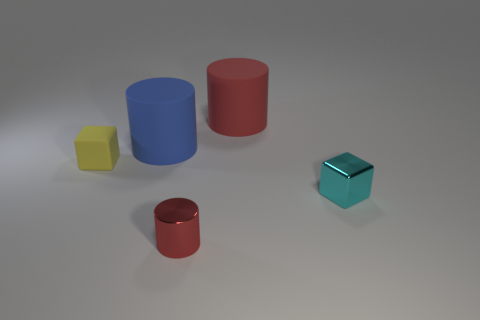What is the color of the other tiny metal thing that is the same shape as the tiny yellow object?
Make the answer very short. Cyan. What number of small red shiny objects are the same shape as the big red rubber thing?
Ensure brevity in your answer.  1. What number of things are either tiny rubber objects or red objects that are behind the tiny cylinder?
Your answer should be very brief. 2. There is a small shiny cube; does it have the same color as the block behind the tiny cyan object?
Offer a terse response. No. There is a cylinder that is in front of the red rubber thing and behind the red shiny cylinder; what is its size?
Provide a succinct answer. Large. There is a small red cylinder; are there any big things on the right side of it?
Your response must be concise. Yes. There is a small block that is right of the rubber block; are there any small metallic objects right of it?
Provide a succinct answer. No. Are there the same number of things that are in front of the yellow rubber block and cyan blocks on the right side of the large blue matte cylinder?
Provide a succinct answer. No. The cylinder that is the same material as the blue object is what color?
Offer a very short reply. Red. Are there any small yellow objects made of the same material as the blue cylinder?
Provide a succinct answer. Yes. 